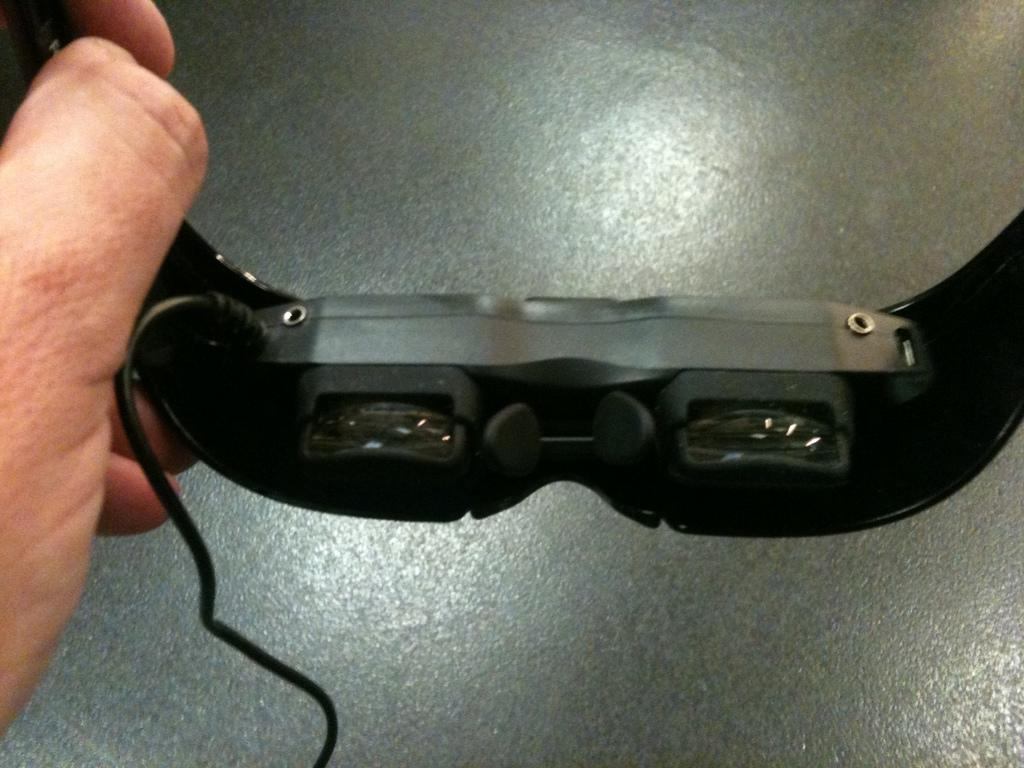What is the person's hand holding in the image? The hand is holding goggles. What can be seen below the hand in the image? There is a floor visible in the image. How many legs can be seen in the image? There are no legs visible in the image; only a hand holding goggles and a floor are present. 